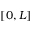<formula> <loc_0><loc_0><loc_500><loc_500>[ 0 , L ]</formula> 